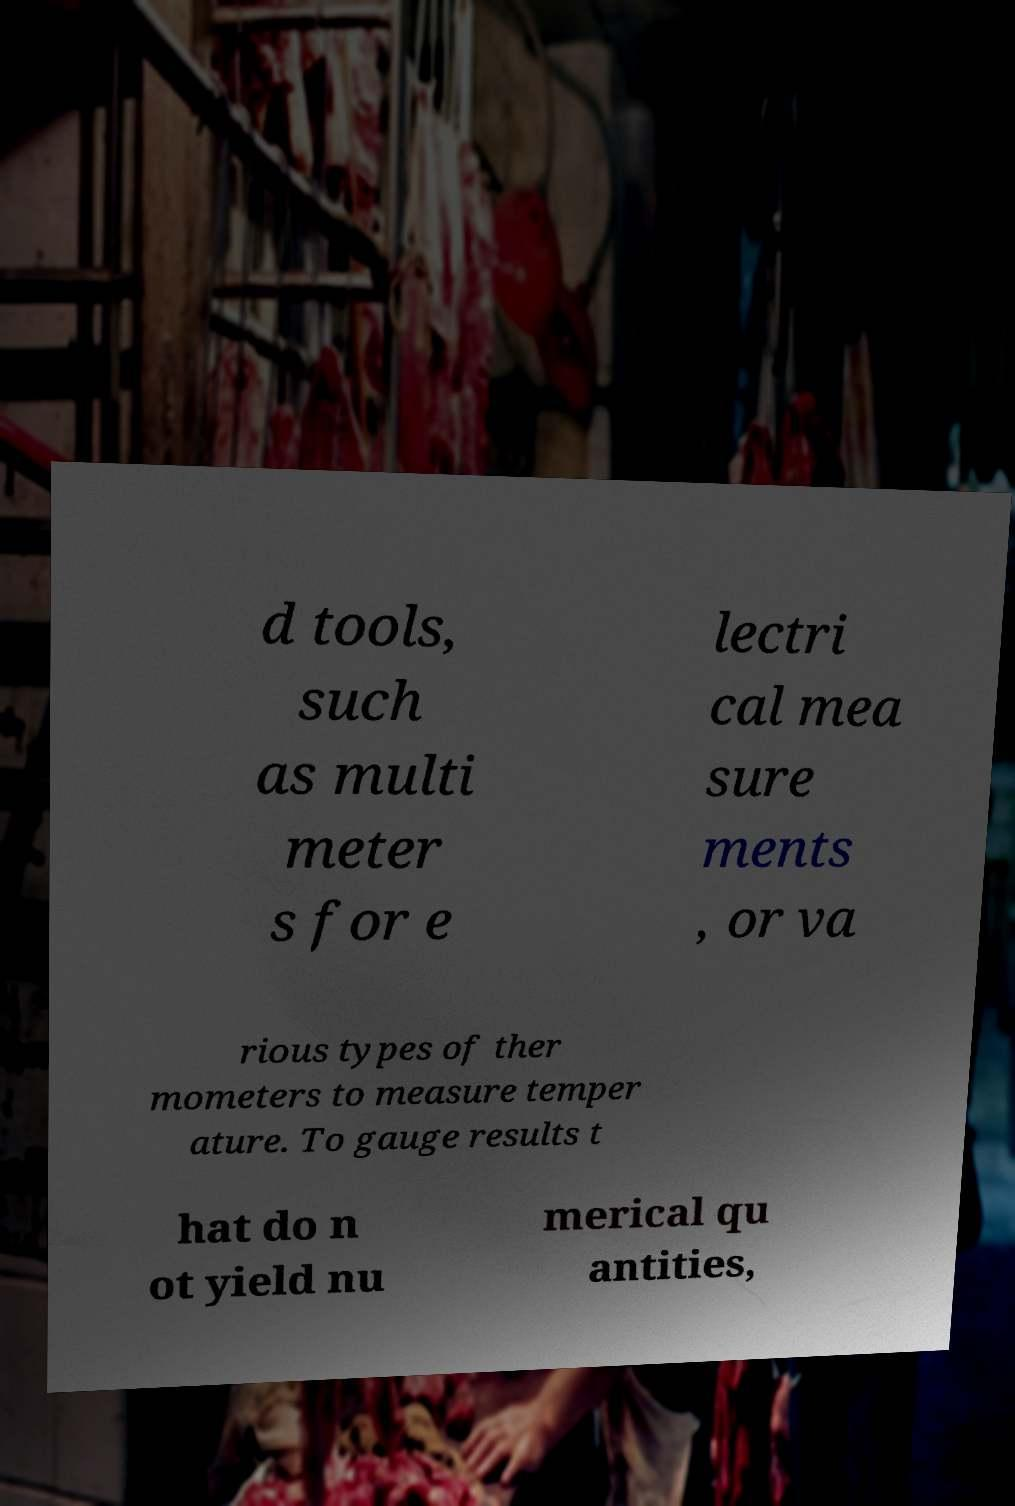Could you assist in decoding the text presented in this image and type it out clearly? d tools, such as multi meter s for e lectri cal mea sure ments , or va rious types of ther mometers to measure temper ature. To gauge results t hat do n ot yield nu merical qu antities, 